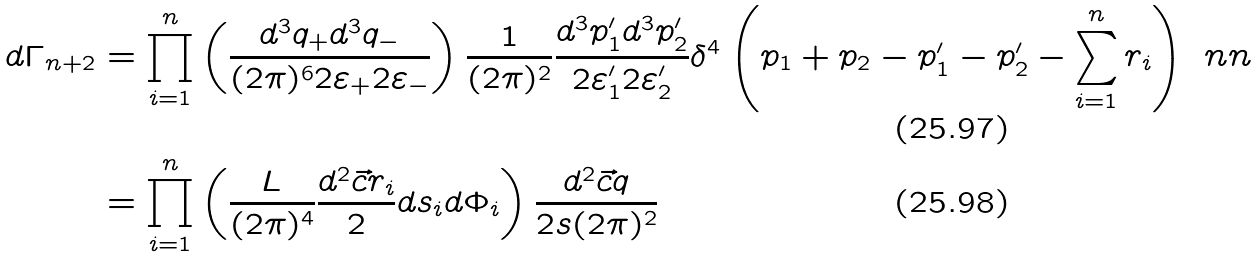Convert formula to latex. <formula><loc_0><loc_0><loc_500><loc_500>d \Gamma _ { n + 2 } & = \prod _ { i = 1 } ^ { n } \left ( \frac { d ^ { 3 } q _ { + } d ^ { 3 } q _ { - } } { ( 2 \pi ) ^ { 6 } 2 \varepsilon _ { + } 2 \varepsilon _ { - } } \right ) \frac { 1 } { ( 2 \pi ) ^ { 2 } } \frac { d ^ { 3 } p _ { 1 } ^ { \prime } d ^ { 3 } p _ { 2 } ^ { \prime } } { 2 \varepsilon _ { 1 } ^ { \prime } 2 \varepsilon _ { 2 } ^ { \prime } } \delta ^ { 4 } \left ( p _ { 1 } + p _ { 2 } - p _ { 1 } ^ { \prime } - p _ { 2 } ^ { \prime } - \sum _ { i = 1 } ^ { n } r _ { i } \right ) \ n n \\ & = \prod _ { i = 1 } ^ { n } \left ( \frac { L } { ( 2 \pi ) ^ { 4 } } \frac { d ^ { 2 } \vec { c } { r _ { i } } } { 2 } d s _ { i } d \Phi _ { i } \right ) \frac { d ^ { 2 } \vec { c } { q } } { 2 s ( 2 \pi ) ^ { 2 } }</formula> 